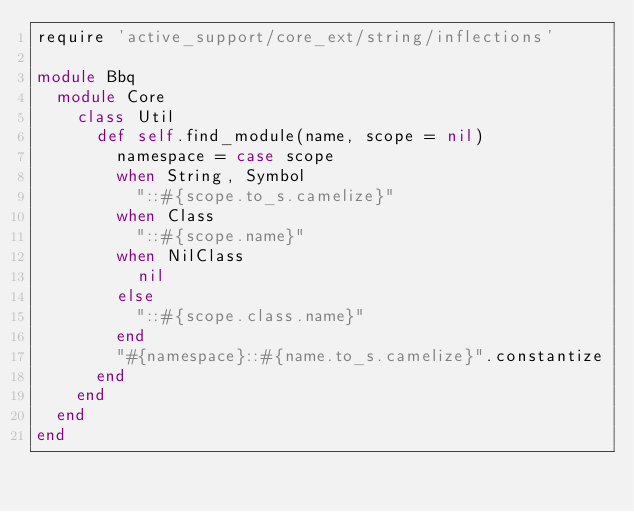Convert code to text. <code><loc_0><loc_0><loc_500><loc_500><_Ruby_>require 'active_support/core_ext/string/inflections'

module Bbq
  module Core
    class Util
      def self.find_module(name, scope = nil)
        namespace = case scope
        when String, Symbol
          "::#{scope.to_s.camelize}"
        when Class
          "::#{scope.name}"
        when NilClass
          nil
        else
          "::#{scope.class.name}"
        end
        "#{namespace}::#{name.to_s.camelize}".constantize
      end
    end
  end
end
</code> 